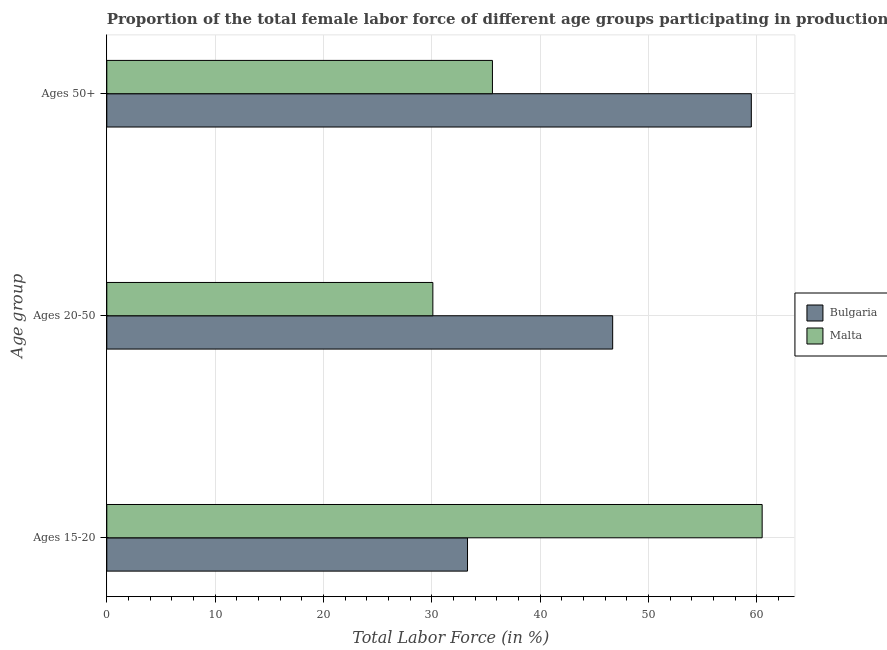Are the number of bars on each tick of the Y-axis equal?
Offer a terse response. Yes. How many bars are there on the 3rd tick from the top?
Make the answer very short. 2. How many bars are there on the 2nd tick from the bottom?
Offer a very short reply. 2. What is the label of the 2nd group of bars from the top?
Make the answer very short. Ages 20-50. What is the percentage of female labor force within the age group 20-50 in Bulgaria?
Keep it short and to the point. 46.7. Across all countries, what is the maximum percentage of female labor force within the age group 20-50?
Your response must be concise. 46.7. Across all countries, what is the minimum percentage of female labor force within the age group 20-50?
Offer a very short reply. 30.1. In which country was the percentage of female labor force within the age group 20-50 minimum?
Provide a short and direct response. Malta. What is the total percentage of female labor force within the age group 20-50 in the graph?
Your answer should be compact. 76.8. What is the difference between the percentage of female labor force within the age group 15-20 in Bulgaria and that in Malta?
Your response must be concise. -27.2. What is the average percentage of female labor force within the age group 15-20 per country?
Provide a succinct answer. 46.9. What is the difference between the percentage of female labor force within the age group 15-20 and percentage of female labor force above age 50 in Bulgaria?
Provide a succinct answer. -26.2. In how many countries, is the percentage of female labor force within the age group 15-20 greater than 16 %?
Your response must be concise. 2. What is the ratio of the percentage of female labor force within the age group 15-20 in Malta to that in Bulgaria?
Ensure brevity in your answer.  1.82. What is the difference between the highest and the second highest percentage of female labor force within the age group 15-20?
Provide a succinct answer. 27.2. What is the difference between the highest and the lowest percentage of female labor force within the age group 15-20?
Provide a succinct answer. 27.2. What does the 1st bar from the top in Ages 15-20 represents?
Give a very brief answer. Malta. What does the 2nd bar from the bottom in Ages 50+ represents?
Your response must be concise. Malta. How many bars are there?
Keep it short and to the point. 6. How many countries are there in the graph?
Your answer should be very brief. 2. What is the difference between two consecutive major ticks on the X-axis?
Your response must be concise. 10. Does the graph contain any zero values?
Your answer should be very brief. No. Does the graph contain grids?
Ensure brevity in your answer.  Yes. Where does the legend appear in the graph?
Provide a short and direct response. Center right. How many legend labels are there?
Your answer should be compact. 2. How are the legend labels stacked?
Provide a succinct answer. Vertical. What is the title of the graph?
Give a very brief answer. Proportion of the total female labor force of different age groups participating in production in 2001. What is the label or title of the Y-axis?
Provide a short and direct response. Age group. What is the Total Labor Force (in %) of Bulgaria in Ages 15-20?
Provide a short and direct response. 33.3. What is the Total Labor Force (in %) of Malta in Ages 15-20?
Offer a terse response. 60.5. What is the Total Labor Force (in %) of Bulgaria in Ages 20-50?
Your response must be concise. 46.7. What is the Total Labor Force (in %) of Malta in Ages 20-50?
Your response must be concise. 30.1. What is the Total Labor Force (in %) of Bulgaria in Ages 50+?
Offer a very short reply. 59.5. What is the Total Labor Force (in %) in Malta in Ages 50+?
Your response must be concise. 35.6. Across all Age group, what is the maximum Total Labor Force (in %) of Bulgaria?
Offer a very short reply. 59.5. Across all Age group, what is the maximum Total Labor Force (in %) in Malta?
Offer a very short reply. 60.5. Across all Age group, what is the minimum Total Labor Force (in %) in Bulgaria?
Offer a terse response. 33.3. Across all Age group, what is the minimum Total Labor Force (in %) in Malta?
Offer a terse response. 30.1. What is the total Total Labor Force (in %) of Bulgaria in the graph?
Provide a short and direct response. 139.5. What is the total Total Labor Force (in %) in Malta in the graph?
Your response must be concise. 126.2. What is the difference between the Total Labor Force (in %) of Malta in Ages 15-20 and that in Ages 20-50?
Provide a short and direct response. 30.4. What is the difference between the Total Labor Force (in %) of Bulgaria in Ages 15-20 and that in Ages 50+?
Your answer should be very brief. -26.2. What is the difference between the Total Labor Force (in %) of Malta in Ages 15-20 and that in Ages 50+?
Give a very brief answer. 24.9. What is the difference between the Total Labor Force (in %) of Bulgaria in Ages 20-50 and that in Ages 50+?
Provide a short and direct response. -12.8. What is the difference between the Total Labor Force (in %) in Bulgaria in Ages 15-20 and the Total Labor Force (in %) in Malta in Ages 50+?
Ensure brevity in your answer.  -2.3. What is the difference between the Total Labor Force (in %) in Bulgaria in Ages 20-50 and the Total Labor Force (in %) in Malta in Ages 50+?
Make the answer very short. 11.1. What is the average Total Labor Force (in %) in Bulgaria per Age group?
Give a very brief answer. 46.5. What is the average Total Labor Force (in %) in Malta per Age group?
Give a very brief answer. 42.07. What is the difference between the Total Labor Force (in %) in Bulgaria and Total Labor Force (in %) in Malta in Ages 15-20?
Your response must be concise. -27.2. What is the difference between the Total Labor Force (in %) in Bulgaria and Total Labor Force (in %) in Malta in Ages 50+?
Keep it short and to the point. 23.9. What is the ratio of the Total Labor Force (in %) of Bulgaria in Ages 15-20 to that in Ages 20-50?
Your answer should be compact. 0.71. What is the ratio of the Total Labor Force (in %) of Malta in Ages 15-20 to that in Ages 20-50?
Offer a very short reply. 2.01. What is the ratio of the Total Labor Force (in %) of Bulgaria in Ages 15-20 to that in Ages 50+?
Offer a very short reply. 0.56. What is the ratio of the Total Labor Force (in %) of Malta in Ages 15-20 to that in Ages 50+?
Keep it short and to the point. 1.7. What is the ratio of the Total Labor Force (in %) in Bulgaria in Ages 20-50 to that in Ages 50+?
Your answer should be very brief. 0.78. What is the ratio of the Total Labor Force (in %) of Malta in Ages 20-50 to that in Ages 50+?
Offer a very short reply. 0.85. What is the difference between the highest and the second highest Total Labor Force (in %) in Malta?
Give a very brief answer. 24.9. What is the difference between the highest and the lowest Total Labor Force (in %) of Bulgaria?
Give a very brief answer. 26.2. What is the difference between the highest and the lowest Total Labor Force (in %) in Malta?
Make the answer very short. 30.4. 